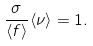<formula> <loc_0><loc_0><loc_500><loc_500>\frac { \sigma } { \langle f \rangle } \langle \nu \rangle = 1 .</formula> 